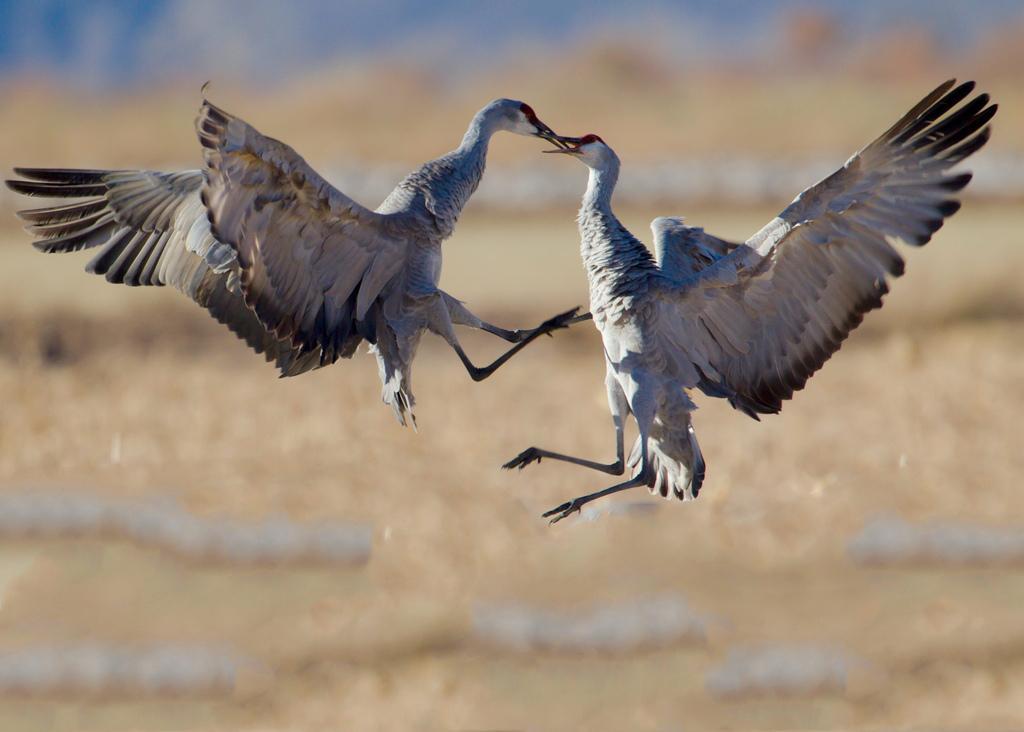Could you give a brief overview of what you see in this image? In this picture there are two birds in the center of the image. 